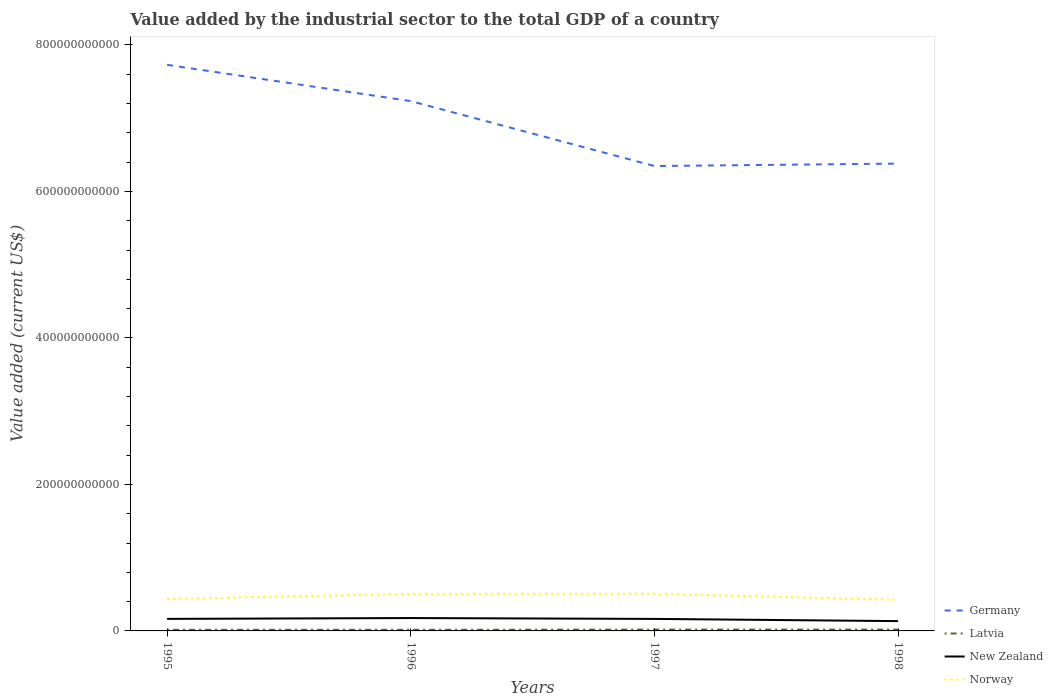How many different coloured lines are there?
Give a very brief answer. 4. Across all years, what is the maximum value added by the industrial sector to the total GDP in New Zealand?
Keep it short and to the point. 1.34e+1. In which year was the value added by the industrial sector to the total GDP in New Zealand maximum?
Your response must be concise. 1998. What is the total value added by the industrial sector to the total GDP in New Zealand in the graph?
Offer a terse response. 1.18e+09. What is the difference between the highest and the second highest value added by the industrial sector to the total GDP in Germany?
Your response must be concise. 1.38e+11. What is the difference between the highest and the lowest value added by the industrial sector to the total GDP in New Zealand?
Your answer should be very brief. 3. How many years are there in the graph?
Give a very brief answer. 4. What is the difference between two consecutive major ticks on the Y-axis?
Ensure brevity in your answer.  2.00e+11. Does the graph contain any zero values?
Your answer should be compact. No. Where does the legend appear in the graph?
Make the answer very short. Bottom right. How many legend labels are there?
Provide a short and direct response. 4. What is the title of the graph?
Your answer should be very brief. Value added by the industrial sector to the total GDP of a country. Does "Cambodia" appear as one of the legend labels in the graph?
Ensure brevity in your answer.  No. What is the label or title of the X-axis?
Your answer should be very brief. Years. What is the label or title of the Y-axis?
Your answer should be very brief. Value added (current US$). What is the Value added (current US$) of Germany in 1995?
Provide a succinct answer. 7.73e+11. What is the Value added (current US$) in Latvia in 1995?
Keep it short and to the point. 1.55e+09. What is the Value added (current US$) of New Zealand in 1995?
Your answer should be very brief. 1.64e+1. What is the Value added (current US$) of Norway in 1995?
Your response must be concise. 4.38e+1. What is the Value added (current US$) in Germany in 1996?
Keep it short and to the point. 7.23e+11. What is the Value added (current US$) in Latvia in 1996?
Your answer should be very brief. 1.59e+09. What is the Value added (current US$) in New Zealand in 1996?
Provide a short and direct response. 1.76e+1. What is the Value added (current US$) of Norway in 1996?
Your answer should be compact. 5.06e+1. What is the Value added (current US$) in Germany in 1997?
Your answer should be compact. 6.35e+11. What is the Value added (current US$) in Latvia in 1997?
Keep it short and to the point. 1.83e+09. What is the Value added (current US$) of New Zealand in 1997?
Your response must be concise. 1.64e+1. What is the Value added (current US$) in Norway in 1997?
Keep it short and to the point. 5.08e+1. What is the Value added (current US$) of Germany in 1998?
Give a very brief answer. 6.38e+11. What is the Value added (current US$) of Latvia in 1998?
Keep it short and to the point. 1.85e+09. What is the Value added (current US$) in New Zealand in 1998?
Give a very brief answer. 1.34e+1. What is the Value added (current US$) in Norway in 1998?
Your answer should be very brief. 4.25e+1. Across all years, what is the maximum Value added (current US$) in Germany?
Give a very brief answer. 7.73e+11. Across all years, what is the maximum Value added (current US$) in Latvia?
Offer a very short reply. 1.85e+09. Across all years, what is the maximum Value added (current US$) of New Zealand?
Your answer should be very brief. 1.76e+1. Across all years, what is the maximum Value added (current US$) of Norway?
Make the answer very short. 5.08e+1. Across all years, what is the minimum Value added (current US$) in Germany?
Your answer should be very brief. 6.35e+11. Across all years, what is the minimum Value added (current US$) in Latvia?
Offer a terse response. 1.55e+09. Across all years, what is the minimum Value added (current US$) of New Zealand?
Ensure brevity in your answer.  1.34e+1. Across all years, what is the minimum Value added (current US$) of Norway?
Your answer should be very brief. 4.25e+1. What is the total Value added (current US$) of Germany in the graph?
Provide a succinct answer. 2.77e+12. What is the total Value added (current US$) in Latvia in the graph?
Make the answer very short. 6.83e+09. What is the total Value added (current US$) in New Zealand in the graph?
Your response must be concise. 6.38e+1. What is the total Value added (current US$) of Norway in the graph?
Offer a very short reply. 1.88e+11. What is the difference between the Value added (current US$) of Germany in 1995 and that in 1996?
Your answer should be compact. 4.95e+1. What is the difference between the Value added (current US$) in Latvia in 1995 and that in 1996?
Ensure brevity in your answer.  -3.86e+07. What is the difference between the Value added (current US$) of New Zealand in 1995 and that in 1996?
Offer a very short reply. -1.14e+09. What is the difference between the Value added (current US$) in Norway in 1995 and that in 1996?
Ensure brevity in your answer.  -6.87e+09. What is the difference between the Value added (current US$) in Germany in 1995 and that in 1997?
Provide a succinct answer. 1.38e+11. What is the difference between the Value added (current US$) of Latvia in 1995 and that in 1997?
Your response must be concise. -2.75e+08. What is the difference between the Value added (current US$) in New Zealand in 1995 and that in 1997?
Provide a succinct answer. 4.70e+07. What is the difference between the Value added (current US$) of Norway in 1995 and that in 1997?
Give a very brief answer. -7.01e+09. What is the difference between the Value added (current US$) in Germany in 1995 and that in 1998?
Provide a short and direct response. 1.35e+11. What is the difference between the Value added (current US$) of Latvia in 1995 and that in 1998?
Your response must be concise. -2.97e+08. What is the difference between the Value added (current US$) of New Zealand in 1995 and that in 1998?
Your response must be concise. 3.05e+09. What is the difference between the Value added (current US$) of Norway in 1995 and that in 1998?
Your answer should be very brief. 1.22e+09. What is the difference between the Value added (current US$) in Germany in 1996 and that in 1997?
Make the answer very short. 8.86e+1. What is the difference between the Value added (current US$) in Latvia in 1996 and that in 1997?
Provide a succinct answer. -2.36e+08. What is the difference between the Value added (current US$) in New Zealand in 1996 and that in 1997?
Make the answer very short. 1.18e+09. What is the difference between the Value added (current US$) in Norway in 1996 and that in 1997?
Make the answer very short. -1.44e+08. What is the difference between the Value added (current US$) in Germany in 1996 and that in 1998?
Provide a short and direct response. 8.53e+1. What is the difference between the Value added (current US$) in Latvia in 1996 and that in 1998?
Offer a terse response. -2.59e+08. What is the difference between the Value added (current US$) of New Zealand in 1996 and that in 1998?
Provide a short and direct response. 4.19e+09. What is the difference between the Value added (current US$) in Norway in 1996 and that in 1998?
Ensure brevity in your answer.  8.09e+09. What is the difference between the Value added (current US$) in Germany in 1997 and that in 1998?
Keep it short and to the point. -3.32e+09. What is the difference between the Value added (current US$) of Latvia in 1997 and that in 1998?
Ensure brevity in your answer.  -2.22e+07. What is the difference between the Value added (current US$) in New Zealand in 1997 and that in 1998?
Ensure brevity in your answer.  3.01e+09. What is the difference between the Value added (current US$) in Norway in 1997 and that in 1998?
Keep it short and to the point. 8.23e+09. What is the difference between the Value added (current US$) of Germany in 1995 and the Value added (current US$) of Latvia in 1996?
Your answer should be very brief. 7.71e+11. What is the difference between the Value added (current US$) of Germany in 1995 and the Value added (current US$) of New Zealand in 1996?
Keep it short and to the point. 7.55e+11. What is the difference between the Value added (current US$) in Germany in 1995 and the Value added (current US$) in Norway in 1996?
Provide a succinct answer. 7.22e+11. What is the difference between the Value added (current US$) in Latvia in 1995 and the Value added (current US$) in New Zealand in 1996?
Provide a succinct answer. -1.60e+1. What is the difference between the Value added (current US$) of Latvia in 1995 and the Value added (current US$) of Norway in 1996?
Give a very brief answer. -4.91e+1. What is the difference between the Value added (current US$) of New Zealand in 1995 and the Value added (current US$) of Norway in 1996?
Ensure brevity in your answer.  -3.42e+1. What is the difference between the Value added (current US$) of Germany in 1995 and the Value added (current US$) of Latvia in 1997?
Give a very brief answer. 7.71e+11. What is the difference between the Value added (current US$) in Germany in 1995 and the Value added (current US$) in New Zealand in 1997?
Keep it short and to the point. 7.56e+11. What is the difference between the Value added (current US$) in Germany in 1995 and the Value added (current US$) in Norway in 1997?
Provide a short and direct response. 7.22e+11. What is the difference between the Value added (current US$) of Latvia in 1995 and the Value added (current US$) of New Zealand in 1997?
Offer a very short reply. -1.48e+1. What is the difference between the Value added (current US$) of Latvia in 1995 and the Value added (current US$) of Norway in 1997?
Provide a succinct answer. -4.92e+1. What is the difference between the Value added (current US$) in New Zealand in 1995 and the Value added (current US$) in Norway in 1997?
Ensure brevity in your answer.  -3.43e+1. What is the difference between the Value added (current US$) of Germany in 1995 and the Value added (current US$) of Latvia in 1998?
Give a very brief answer. 7.71e+11. What is the difference between the Value added (current US$) in Germany in 1995 and the Value added (current US$) in New Zealand in 1998?
Offer a terse response. 7.59e+11. What is the difference between the Value added (current US$) of Germany in 1995 and the Value added (current US$) of Norway in 1998?
Your response must be concise. 7.30e+11. What is the difference between the Value added (current US$) of Latvia in 1995 and the Value added (current US$) of New Zealand in 1998?
Ensure brevity in your answer.  -1.18e+1. What is the difference between the Value added (current US$) in Latvia in 1995 and the Value added (current US$) in Norway in 1998?
Ensure brevity in your answer.  -4.10e+1. What is the difference between the Value added (current US$) in New Zealand in 1995 and the Value added (current US$) in Norway in 1998?
Your response must be concise. -2.61e+1. What is the difference between the Value added (current US$) in Germany in 1996 and the Value added (current US$) in Latvia in 1997?
Give a very brief answer. 7.21e+11. What is the difference between the Value added (current US$) in Germany in 1996 and the Value added (current US$) in New Zealand in 1997?
Provide a short and direct response. 7.07e+11. What is the difference between the Value added (current US$) in Germany in 1996 and the Value added (current US$) in Norway in 1997?
Keep it short and to the point. 6.73e+11. What is the difference between the Value added (current US$) of Latvia in 1996 and the Value added (current US$) of New Zealand in 1997?
Offer a terse response. -1.48e+1. What is the difference between the Value added (current US$) in Latvia in 1996 and the Value added (current US$) in Norway in 1997?
Offer a very short reply. -4.92e+1. What is the difference between the Value added (current US$) of New Zealand in 1996 and the Value added (current US$) of Norway in 1997?
Provide a short and direct response. -3.32e+1. What is the difference between the Value added (current US$) of Germany in 1996 and the Value added (current US$) of Latvia in 1998?
Keep it short and to the point. 7.21e+11. What is the difference between the Value added (current US$) of Germany in 1996 and the Value added (current US$) of New Zealand in 1998?
Your answer should be compact. 7.10e+11. What is the difference between the Value added (current US$) of Germany in 1996 and the Value added (current US$) of Norway in 1998?
Make the answer very short. 6.81e+11. What is the difference between the Value added (current US$) of Latvia in 1996 and the Value added (current US$) of New Zealand in 1998?
Keep it short and to the point. -1.18e+1. What is the difference between the Value added (current US$) in Latvia in 1996 and the Value added (current US$) in Norway in 1998?
Your response must be concise. -4.10e+1. What is the difference between the Value added (current US$) of New Zealand in 1996 and the Value added (current US$) of Norway in 1998?
Provide a succinct answer. -2.50e+1. What is the difference between the Value added (current US$) of Germany in 1997 and the Value added (current US$) of Latvia in 1998?
Keep it short and to the point. 6.33e+11. What is the difference between the Value added (current US$) in Germany in 1997 and the Value added (current US$) in New Zealand in 1998?
Your answer should be very brief. 6.21e+11. What is the difference between the Value added (current US$) of Germany in 1997 and the Value added (current US$) of Norway in 1998?
Ensure brevity in your answer.  5.92e+11. What is the difference between the Value added (current US$) in Latvia in 1997 and the Value added (current US$) in New Zealand in 1998?
Provide a succinct answer. -1.16e+1. What is the difference between the Value added (current US$) in Latvia in 1997 and the Value added (current US$) in Norway in 1998?
Offer a very short reply. -4.07e+1. What is the difference between the Value added (current US$) of New Zealand in 1997 and the Value added (current US$) of Norway in 1998?
Your response must be concise. -2.62e+1. What is the average Value added (current US$) in Germany per year?
Your answer should be very brief. 6.92e+11. What is the average Value added (current US$) in Latvia per year?
Your response must be concise. 1.71e+09. What is the average Value added (current US$) of New Zealand per year?
Your answer should be very brief. 1.60e+1. What is the average Value added (current US$) in Norway per year?
Keep it short and to the point. 4.69e+1. In the year 1995, what is the difference between the Value added (current US$) of Germany and Value added (current US$) of Latvia?
Ensure brevity in your answer.  7.71e+11. In the year 1995, what is the difference between the Value added (current US$) of Germany and Value added (current US$) of New Zealand?
Give a very brief answer. 7.56e+11. In the year 1995, what is the difference between the Value added (current US$) in Germany and Value added (current US$) in Norway?
Provide a succinct answer. 7.29e+11. In the year 1995, what is the difference between the Value added (current US$) in Latvia and Value added (current US$) in New Zealand?
Offer a terse response. -1.49e+1. In the year 1995, what is the difference between the Value added (current US$) of Latvia and Value added (current US$) of Norway?
Keep it short and to the point. -4.22e+1. In the year 1995, what is the difference between the Value added (current US$) of New Zealand and Value added (current US$) of Norway?
Your answer should be compact. -2.73e+1. In the year 1996, what is the difference between the Value added (current US$) in Germany and Value added (current US$) in Latvia?
Make the answer very short. 7.22e+11. In the year 1996, what is the difference between the Value added (current US$) in Germany and Value added (current US$) in New Zealand?
Keep it short and to the point. 7.06e+11. In the year 1996, what is the difference between the Value added (current US$) in Germany and Value added (current US$) in Norway?
Your answer should be very brief. 6.73e+11. In the year 1996, what is the difference between the Value added (current US$) in Latvia and Value added (current US$) in New Zealand?
Make the answer very short. -1.60e+1. In the year 1996, what is the difference between the Value added (current US$) in Latvia and Value added (current US$) in Norway?
Offer a terse response. -4.90e+1. In the year 1996, what is the difference between the Value added (current US$) in New Zealand and Value added (current US$) in Norway?
Your response must be concise. -3.31e+1. In the year 1997, what is the difference between the Value added (current US$) of Germany and Value added (current US$) of Latvia?
Keep it short and to the point. 6.33e+11. In the year 1997, what is the difference between the Value added (current US$) of Germany and Value added (current US$) of New Zealand?
Your response must be concise. 6.18e+11. In the year 1997, what is the difference between the Value added (current US$) in Germany and Value added (current US$) in Norway?
Ensure brevity in your answer.  5.84e+11. In the year 1997, what is the difference between the Value added (current US$) of Latvia and Value added (current US$) of New Zealand?
Ensure brevity in your answer.  -1.46e+1. In the year 1997, what is the difference between the Value added (current US$) in Latvia and Value added (current US$) in Norway?
Keep it short and to the point. -4.90e+1. In the year 1997, what is the difference between the Value added (current US$) of New Zealand and Value added (current US$) of Norway?
Give a very brief answer. -3.44e+1. In the year 1998, what is the difference between the Value added (current US$) in Germany and Value added (current US$) in Latvia?
Give a very brief answer. 6.36e+11. In the year 1998, what is the difference between the Value added (current US$) of Germany and Value added (current US$) of New Zealand?
Offer a terse response. 6.25e+11. In the year 1998, what is the difference between the Value added (current US$) of Germany and Value added (current US$) of Norway?
Your answer should be very brief. 5.95e+11. In the year 1998, what is the difference between the Value added (current US$) in Latvia and Value added (current US$) in New Zealand?
Keep it short and to the point. -1.15e+1. In the year 1998, what is the difference between the Value added (current US$) in Latvia and Value added (current US$) in Norway?
Offer a terse response. -4.07e+1. In the year 1998, what is the difference between the Value added (current US$) of New Zealand and Value added (current US$) of Norway?
Provide a short and direct response. -2.92e+1. What is the ratio of the Value added (current US$) in Germany in 1995 to that in 1996?
Provide a succinct answer. 1.07. What is the ratio of the Value added (current US$) in Latvia in 1995 to that in 1996?
Make the answer very short. 0.98. What is the ratio of the Value added (current US$) in New Zealand in 1995 to that in 1996?
Provide a short and direct response. 0.94. What is the ratio of the Value added (current US$) in Norway in 1995 to that in 1996?
Make the answer very short. 0.86. What is the ratio of the Value added (current US$) in Germany in 1995 to that in 1997?
Your answer should be very brief. 1.22. What is the ratio of the Value added (current US$) in Latvia in 1995 to that in 1997?
Your answer should be compact. 0.85. What is the ratio of the Value added (current US$) of Norway in 1995 to that in 1997?
Offer a very short reply. 0.86. What is the ratio of the Value added (current US$) in Germany in 1995 to that in 1998?
Your response must be concise. 1.21. What is the ratio of the Value added (current US$) of Latvia in 1995 to that in 1998?
Your answer should be very brief. 0.84. What is the ratio of the Value added (current US$) of New Zealand in 1995 to that in 1998?
Your answer should be very brief. 1.23. What is the ratio of the Value added (current US$) of Norway in 1995 to that in 1998?
Offer a very short reply. 1.03. What is the ratio of the Value added (current US$) in Germany in 1996 to that in 1997?
Your answer should be compact. 1.14. What is the ratio of the Value added (current US$) of Latvia in 1996 to that in 1997?
Make the answer very short. 0.87. What is the ratio of the Value added (current US$) of New Zealand in 1996 to that in 1997?
Offer a very short reply. 1.07. What is the ratio of the Value added (current US$) in Germany in 1996 to that in 1998?
Offer a very short reply. 1.13. What is the ratio of the Value added (current US$) in Latvia in 1996 to that in 1998?
Ensure brevity in your answer.  0.86. What is the ratio of the Value added (current US$) in New Zealand in 1996 to that in 1998?
Provide a short and direct response. 1.31. What is the ratio of the Value added (current US$) in Norway in 1996 to that in 1998?
Keep it short and to the point. 1.19. What is the ratio of the Value added (current US$) in Germany in 1997 to that in 1998?
Offer a terse response. 0.99. What is the ratio of the Value added (current US$) of New Zealand in 1997 to that in 1998?
Your response must be concise. 1.22. What is the ratio of the Value added (current US$) in Norway in 1997 to that in 1998?
Offer a terse response. 1.19. What is the difference between the highest and the second highest Value added (current US$) in Germany?
Make the answer very short. 4.95e+1. What is the difference between the highest and the second highest Value added (current US$) in Latvia?
Your answer should be compact. 2.22e+07. What is the difference between the highest and the second highest Value added (current US$) of New Zealand?
Offer a very short reply. 1.14e+09. What is the difference between the highest and the second highest Value added (current US$) of Norway?
Provide a succinct answer. 1.44e+08. What is the difference between the highest and the lowest Value added (current US$) in Germany?
Your response must be concise. 1.38e+11. What is the difference between the highest and the lowest Value added (current US$) of Latvia?
Keep it short and to the point. 2.97e+08. What is the difference between the highest and the lowest Value added (current US$) of New Zealand?
Give a very brief answer. 4.19e+09. What is the difference between the highest and the lowest Value added (current US$) of Norway?
Offer a terse response. 8.23e+09. 